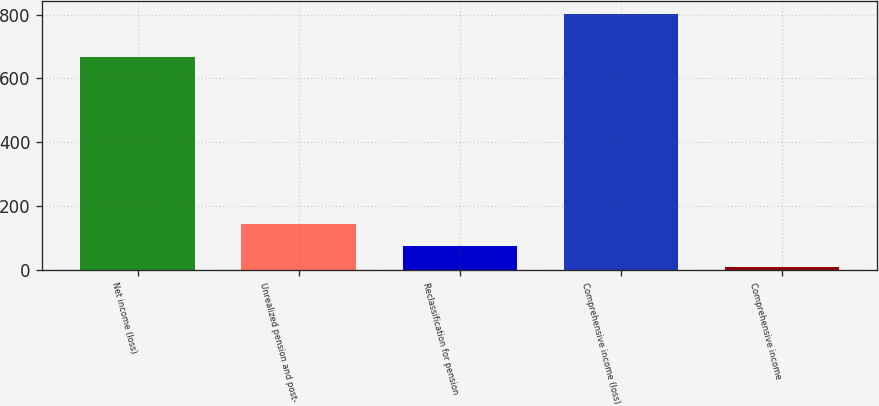<chart> <loc_0><loc_0><loc_500><loc_500><bar_chart><fcel>Net income (loss)<fcel>Unrealized pension and post-<fcel>Reclassification for pension<fcel>Comprehensive income (loss)<fcel>Comprehensive income<nl><fcel>665.9<fcel>143.92<fcel>75.41<fcel>802.92<fcel>6.9<nl></chart> 